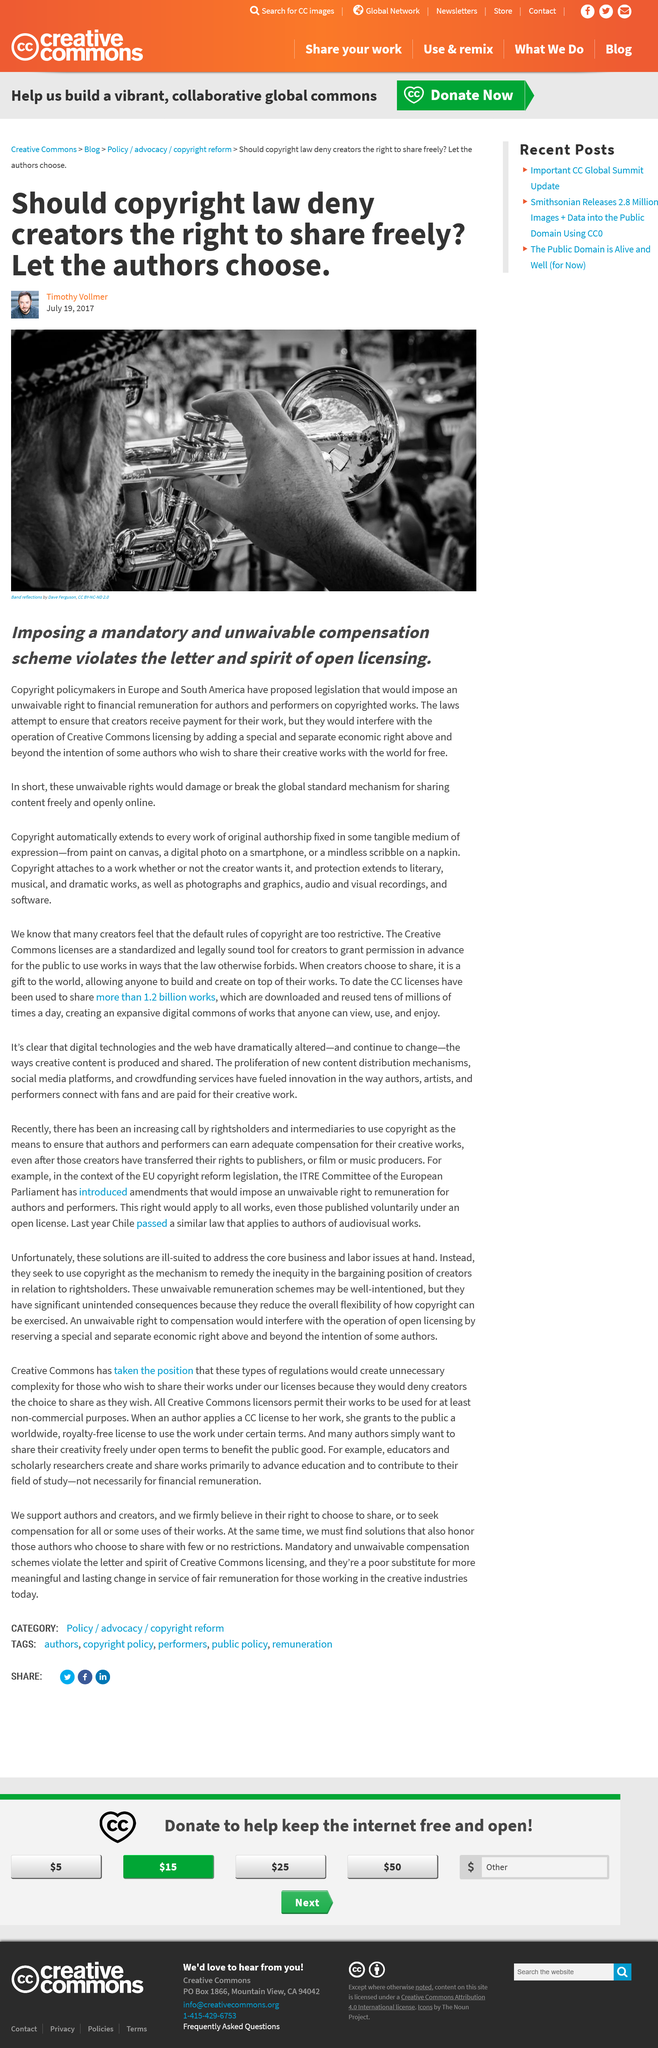Give some essential details in this illustration. Some authors desire to distribute their work freely to the general public without any charge or limitations. A compensation scheme that violates the letter and spirit of open licensing goes against the principles of transparency, accessibility, and reuse that underlie open licensing. Policymakers in Europe and South America are proposing new legislation. 